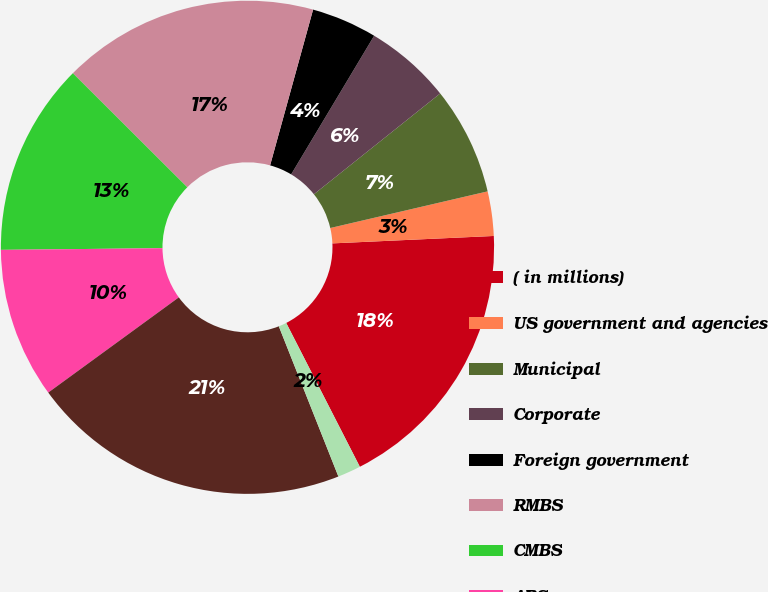Convert chart. <chart><loc_0><loc_0><loc_500><loc_500><pie_chart><fcel>( in millions)<fcel>US government and agencies<fcel>Municipal<fcel>Corporate<fcel>Foreign government<fcel>RMBS<fcel>CMBS<fcel>ABS<fcel>Fixed income securities (1)<fcel>Equity securities<nl><fcel>18.2%<fcel>2.91%<fcel>7.08%<fcel>5.69%<fcel>4.3%<fcel>16.81%<fcel>12.64%<fcel>9.86%<fcel>20.98%<fcel>1.52%<nl></chart> 